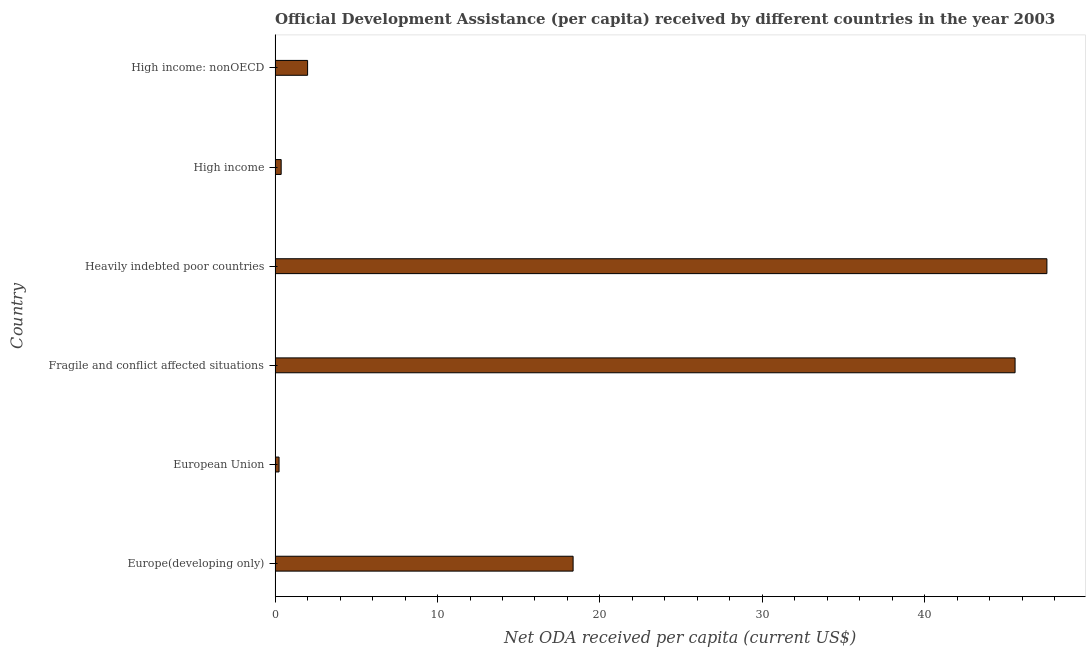What is the title of the graph?
Your response must be concise. Official Development Assistance (per capita) received by different countries in the year 2003. What is the label or title of the X-axis?
Your answer should be very brief. Net ODA received per capita (current US$). What is the label or title of the Y-axis?
Make the answer very short. Country. What is the net oda received per capita in Fragile and conflict affected situations?
Your answer should be very brief. 45.56. Across all countries, what is the maximum net oda received per capita?
Give a very brief answer. 47.52. Across all countries, what is the minimum net oda received per capita?
Your answer should be very brief. 0.25. In which country was the net oda received per capita maximum?
Provide a succinct answer. Heavily indebted poor countries. In which country was the net oda received per capita minimum?
Make the answer very short. European Union. What is the sum of the net oda received per capita?
Offer a terse response. 114.04. What is the difference between the net oda received per capita in Heavily indebted poor countries and High income?
Offer a very short reply. 47.14. What is the average net oda received per capita per country?
Give a very brief answer. 19.01. What is the median net oda received per capita?
Your answer should be compact. 10.17. What is the ratio of the net oda received per capita in Europe(developing only) to that in Heavily indebted poor countries?
Provide a short and direct response. 0.39. Is the net oda received per capita in European Union less than that in Fragile and conflict affected situations?
Your answer should be compact. Yes. What is the difference between the highest and the second highest net oda received per capita?
Your answer should be compact. 1.96. Is the sum of the net oda received per capita in Europe(developing only) and High income: nonOECD greater than the maximum net oda received per capita across all countries?
Provide a short and direct response. No. What is the difference between the highest and the lowest net oda received per capita?
Your answer should be very brief. 47.27. How many bars are there?
Give a very brief answer. 6. Are all the bars in the graph horizontal?
Give a very brief answer. Yes. How many countries are there in the graph?
Your answer should be compact. 6. What is the difference between two consecutive major ticks on the X-axis?
Ensure brevity in your answer.  10. Are the values on the major ticks of X-axis written in scientific E-notation?
Offer a terse response. No. What is the Net ODA received per capita (current US$) of Europe(developing only)?
Your answer should be compact. 18.35. What is the Net ODA received per capita (current US$) in European Union?
Give a very brief answer. 0.25. What is the Net ODA received per capita (current US$) of Fragile and conflict affected situations?
Provide a short and direct response. 45.56. What is the Net ODA received per capita (current US$) of Heavily indebted poor countries?
Offer a very short reply. 47.52. What is the Net ODA received per capita (current US$) of High income?
Your answer should be compact. 0.38. What is the Net ODA received per capita (current US$) of High income: nonOECD?
Give a very brief answer. 2. What is the difference between the Net ODA received per capita (current US$) in Europe(developing only) and European Union?
Give a very brief answer. 18.1. What is the difference between the Net ODA received per capita (current US$) in Europe(developing only) and Fragile and conflict affected situations?
Make the answer very short. -27.21. What is the difference between the Net ODA received per capita (current US$) in Europe(developing only) and Heavily indebted poor countries?
Provide a succinct answer. -29.17. What is the difference between the Net ODA received per capita (current US$) in Europe(developing only) and High income?
Provide a short and direct response. 17.97. What is the difference between the Net ODA received per capita (current US$) in Europe(developing only) and High income: nonOECD?
Give a very brief answer. 16.35. What is the difference between the Net ODA received per capita (current US$) in European Union and Fragile and conflict affected situations?
Your response must be concise. -45.31. What is the difference between the Net ODA received per capita (current US$) in European Union and Heavily indebted poor countries?
Your answer should be compact. -47.27. What is the difference between the Net ODA received per capita (current US$) in European Union and High income?
Your answer should be compact. -0.13. What is the difference between the Net ODA received per capita (current US$) in European Union and High income: nonOECD?
Keep it short and to the point. -1.76. What is the difference between the Net ODA received per capita (current US$) in Fragile and conflict affected situations and Heavily indebted poor countries?
Ensure brevity in your answer.  -1.96. What is the difference between the Net ODA received per capita (current US$) in Fragile and conflict affected situations and High income?
Keep it short and to the point. 45.18. What is the difference between the Net ODA received per capita (current US$) in Fragile and conflict affected situations and High income: nonOECD?
Offer a terse response. 43.55. What is the difference between the Net ODA received per capita (current US$) in Heavily indebted poor countries and High income?
Offer a terse response. 47.14. What is the difference between the Net ODA received per capita (current US$) in Heavily indebted poor countries and High income: nonOECD?
Give a very brief answer. 45.51. What is the difference between the Net ODA received per capita (current US$) in High income and High income: nonOECD?
Keep it short and to the point. -1.63. What is the ratio of the Net ODA received per capita (current US$) in Europe(developing only) to that in European Union?
Provide a short and direct response. 74.84. What is the ratio of the Net ODA received per capita (current US$) in Europe(developing only) to that in Fragile and conflict affected situations?
Offer a very short reply. 0.4. What is the ratio of the Net ODA received per capita (current US$) in Europe(developing only) to that in Heavily indebted poor countries?
Provide a succinct answer. 0.39. What is the ratio of the Net ODA received per capita (current US$) in Europe(developing only) to that in High income?
Offer a very short reply. 48.89. What is the ratio of the Net ODA received per capita (current US$) in Europe(developing only) to that in High income: nonOECD?
Your answer should be very brief. 9.17. What is the ratio of the Net ODA received per capita (current US$) in European Union to that in Fragile and conflict affected situations?
Your answer should be compact. 0.01. What is the ratio of the Net ODA received per capita (current US$) in European Union to that in Heavily indebted poor countries?
Provide a short and direct response. 0.01. What is the ratio of the Net ODA received per capita (current US$) in European Union to that in High income?
Your answer should be compact. 0.65. What is the ratio of the Net ODA received per capita (current US$) in European Union to that in High income: nonOECD?
Ensure brevity in your answer.  0.12. What is the ratio of the Net ODA received per capita (current US$) in Fragile and conflict affected situations to that in High income?
Provide a short and direct response. 121.4. What is the ratio of the Net ODA received per capita (current US$) in Fragile and conflict affected situations to that in High income: nonOECD?
Ensure brevity in your answer.  22.76. What is the ratio of the Net ODA received per capita (current US$) in Heavily indebted poor countries to that in High income?
Keep it short and to the point. 126.62. What is the ratio of the Net ODA received per capita (current US$) in Heavily indebted poor countries to that in High income: nonOECD?
Offer a very short reply. 23.74. What is the ratio of the Net ODA received per capita (current US$) in High income to that in High income: nonOECD?
Keep it short and to the point. 0.19. 